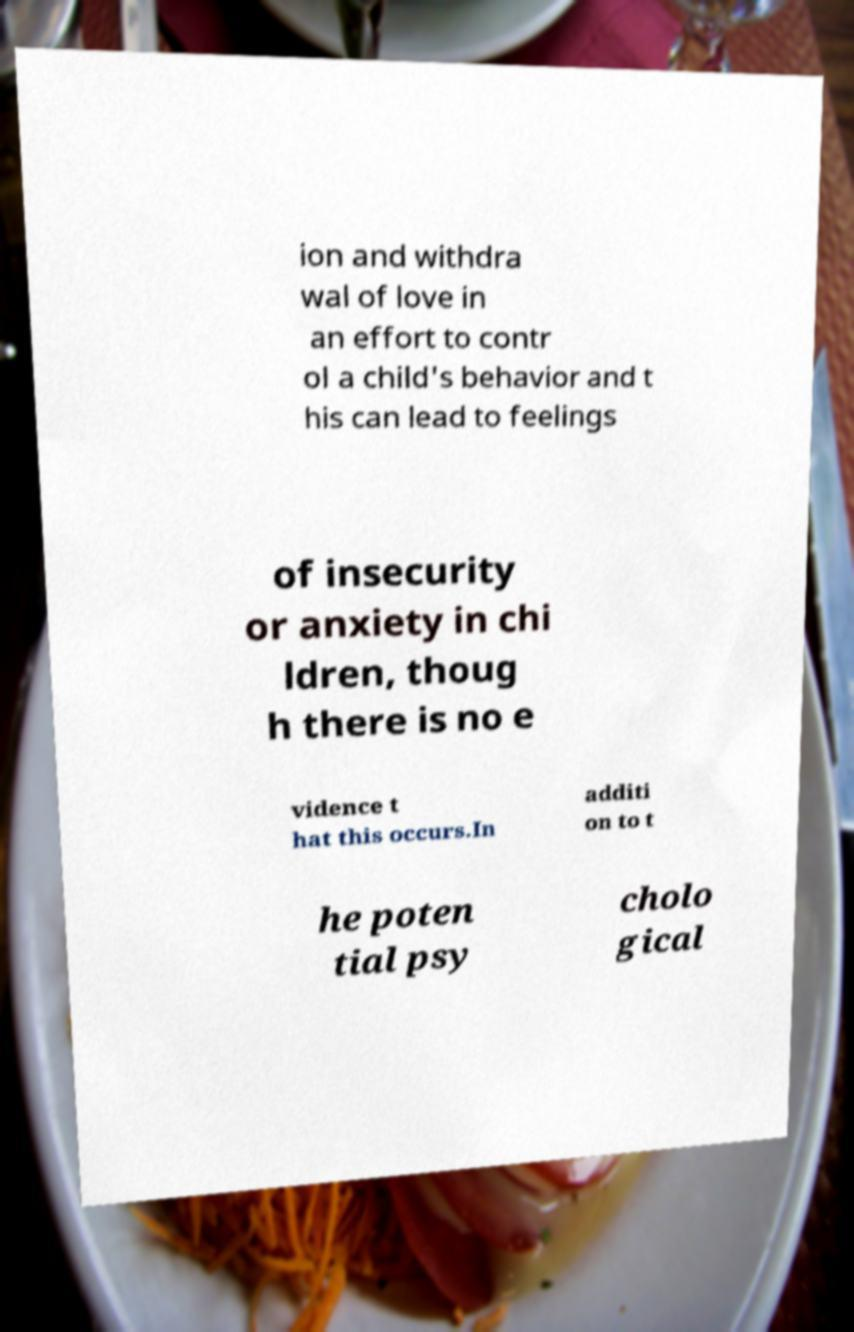There's text embedded in this image that I need extracted. Can you transcribe it verbatim? ion and withdra wal of love in an effort to contr ol a child's behavior and t his can lead to feelings of insecurity or anxiety in chi ldren, thoug h there is no e vidence t hat this occurs.In additi on to t he poten tial psy cholo gical 